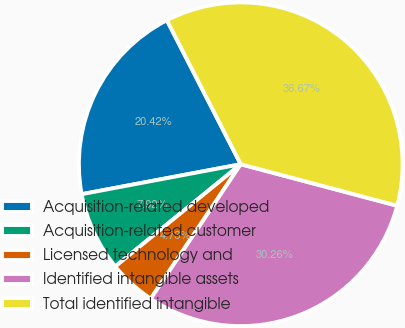Convert chart to OTSL. <chart><loc_0><loc_0><loc_500><loc_500><pie_chart><fcel>Acquisition-related developed<fcel>Acquisition-related customer<fcel>Licensed technology and<fcel>Identified intangible assets<fcel>Total identified intangible<nl><fcel>20.42%<fcel>7.92%<fcel>4.73%<fcel>30.26%<fcel>36.67%<nl></chart> 